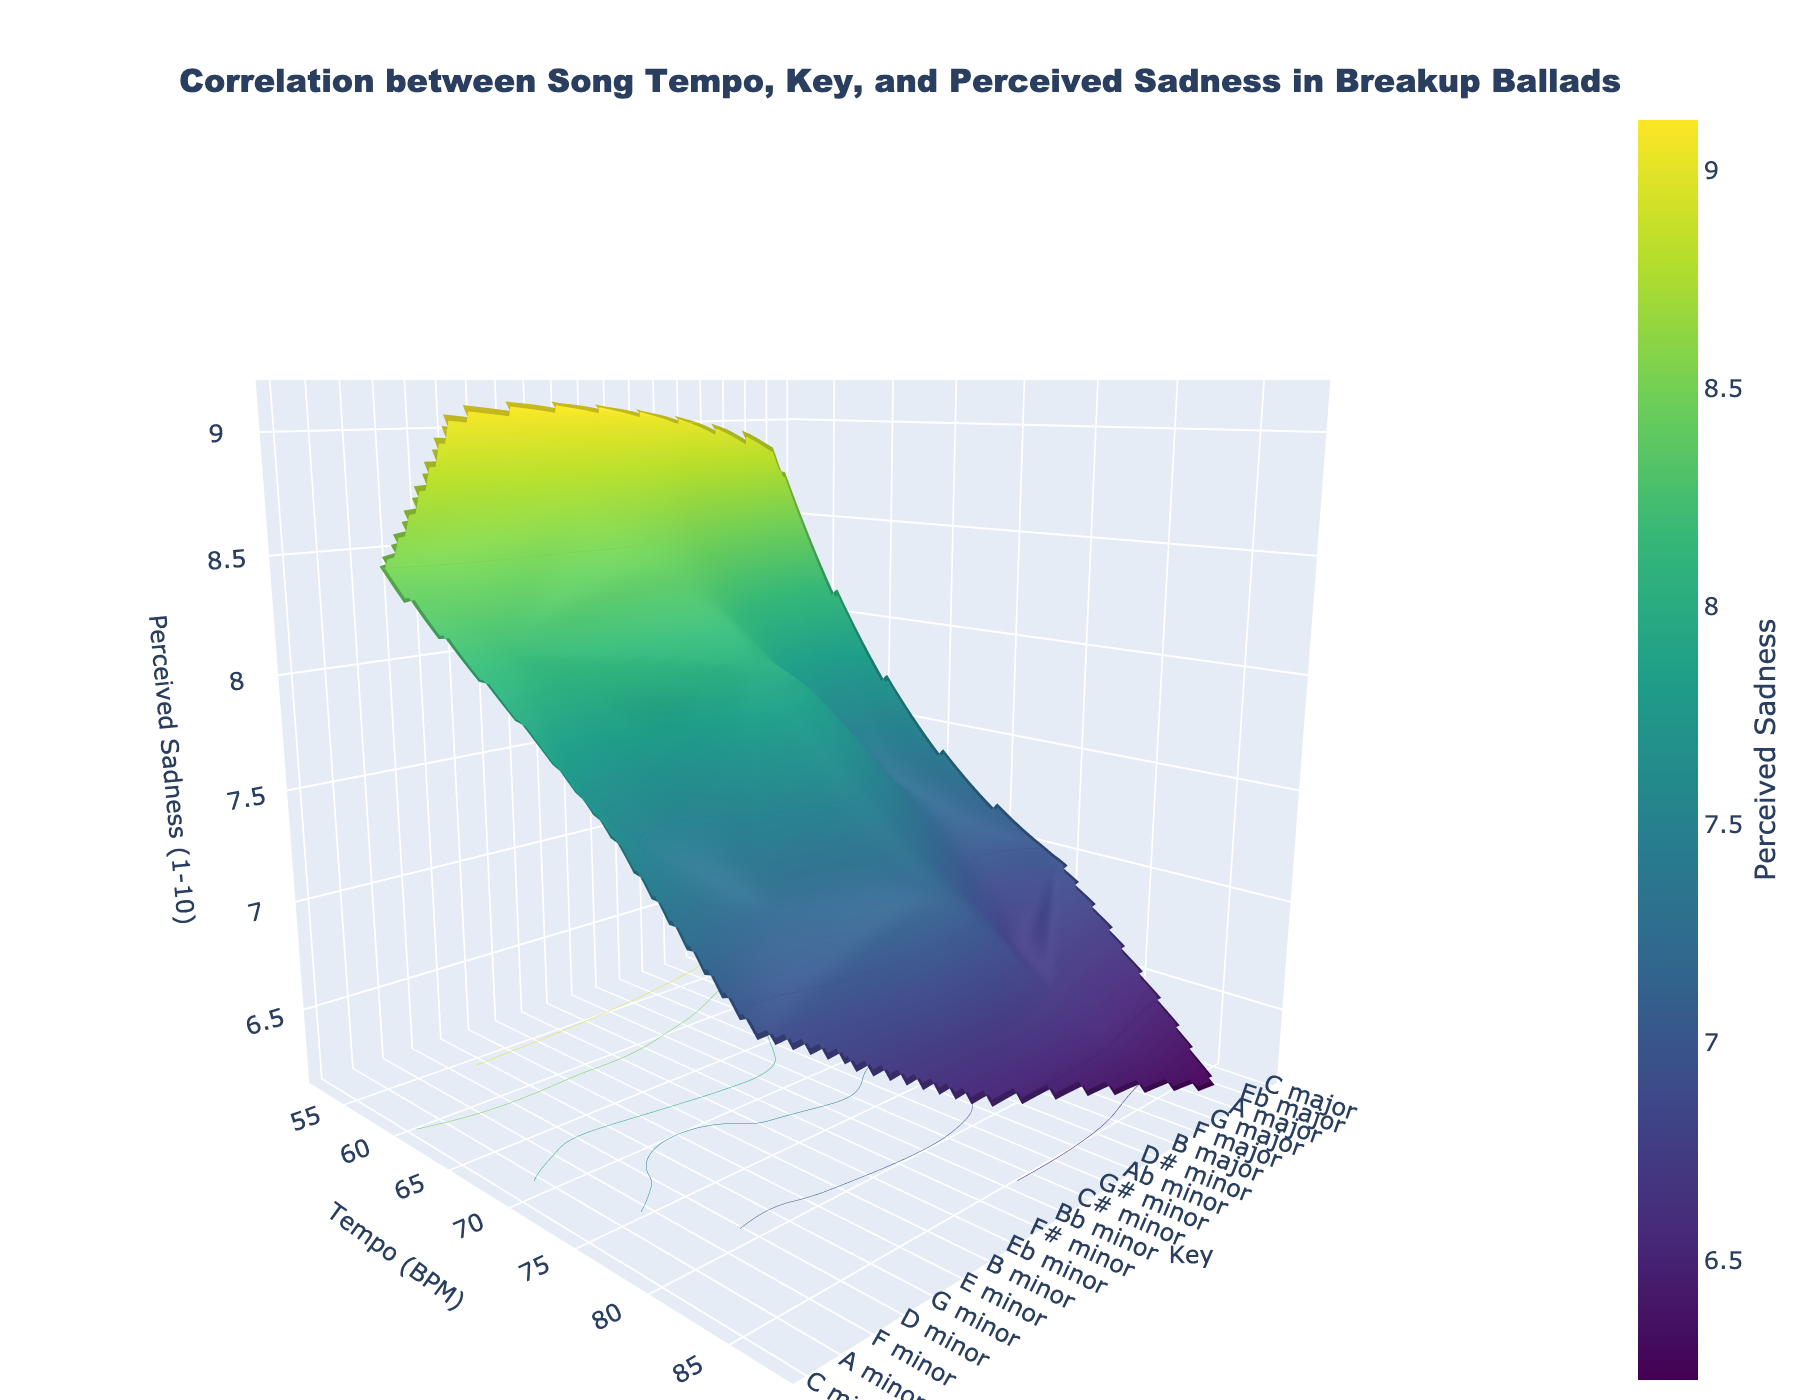What is the title of the 3D surface plot? The title is usually found at the top of the figure and describes what the plot is about. In this case, it mentions the correlation between song tempo, key, and perceived sadness in breakup ballads.
Answer: Correlation between Song Tempo, Key, and Perceived Sadness in Breakup Ballads What are the axes labels on the 3D surface plot? By checking the labels on the three axes in the figure, we can identify that the x-axis represents Tempo in BPM, the y-axis represents Key, and the z-axis represents Perceived Sadness (1-10).
Answer: Tempo (BPM), Key, Perceived Sadness (1-10) Which key appears to have the highest perceived sadness at lower tempos? To answer, observe the areas where sadness peaks in the 3D surface, focusing on the lower tempo range. Here, G minor shows the highest perceived sadness when the tempo is low.
Answer: G minor How does perceived sadness vary with increasing tempo for the key of C minor? We need to follow the line on the surface plot that corresponds to C minor and observe how the perceived sadness values change as the tempo increases. Perceived sadness generally decreases with increasing tempo in C minor.
Answer: Decreases Which key has the lowest perceived sadness at high tempos? Observe high-tempo regions in the surface plot and identify the key with the minimum sadness in this range. A major stands out at high tempo for the lowest sadness.
Answer: A major At what tempo does perceived sadness peak in G# minor? Observe the G# minor line on the plot and pinpoint where the sadness reaches its highest value. This occurs around 54 BPM.
Answer: Around 54 BPM Which key shows the most significant range of perceived sadness as tempo changes? Compare how each key's sadness varies across the tempo axis, looking for a key with large fluctuations. C minor displays substantial variation in sadness across different tempos.
Answer: C minor Is there a general trend in perceived sadness as the tempo increases across most keys? By scanning the plot overall, you can see whether perceived sadness tends to increase or decrease with higher tempos. Generally, perceived sadness tends to decrease as the tempo increases across most keys.
Answer: Decreases In which key does the perceived sadness consistently stay high across a wide range of tempos? Identify the key where the perceived sadness remains high and stable despite variations in tempo. G# minor consistently shows high perceived sadness across various tempos.
Answer: G# minor 